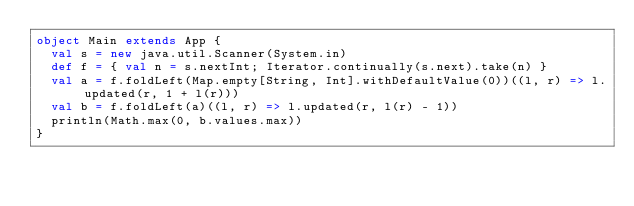Convert code to text. <code><loc_0><loc_0><loc_500><loc_500><_Scala_>object Main extends App {
  val s = new java.util.Scanner(System.in)
  def f = { val n = s.nextInt; Iterator.continually(s.next).take(n) }
  val a = f.foldLeft(Map.empty[String, Int].withDefaultValue(0))((l, r) => l.updated(r, 1 + l(r)))
  val b = f.foldLeft(a)((l, r) => l.updated(r, l(r) - 1))
  println(Math.max(0, b.values.max))
}</code> 